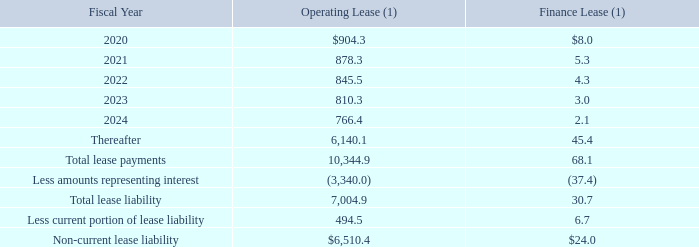AMERICAN TOWER CORPORATION AND SUBSIDIARIES NOTES TO CONSOLIDATED FINANCIAL STATEMENTS (Tabular amounts in millions, unless otherwise disclosed)
As of December 31, 2019, the Company does not have material operating or financing leases that have not yet commenced.
Maturities of operating and finance lease liabilities as of December 31, 2019 were as follows:
(1) Balances are translated at the applicable period-end exchange rate, which may impact comparability between periods.
What was the operating lease in 2020?
Answer scale should be: million. $904.3. What were operating and finance lease balances translated at? The applicable period-end exchange rate, which may impact comparability between periods. What were the total lease payments for operating lease?
Answer scale should be: million. 10,344.9. What was the sum of operating lease in fiscal years 2020-2022?
Answer scale should be: million. $904.3+878.3+845.5
Answer: 2628.1. What was the change in finance leases between 2020 and 2021?
Answer scale should be: million. 5.3-8.0
Answer: -2.7. What is non-current lease liability as a percentage of Total lease liability?
Answer scale should be: percent. 6,510.4/7,004.9
Answer: 92.94. 